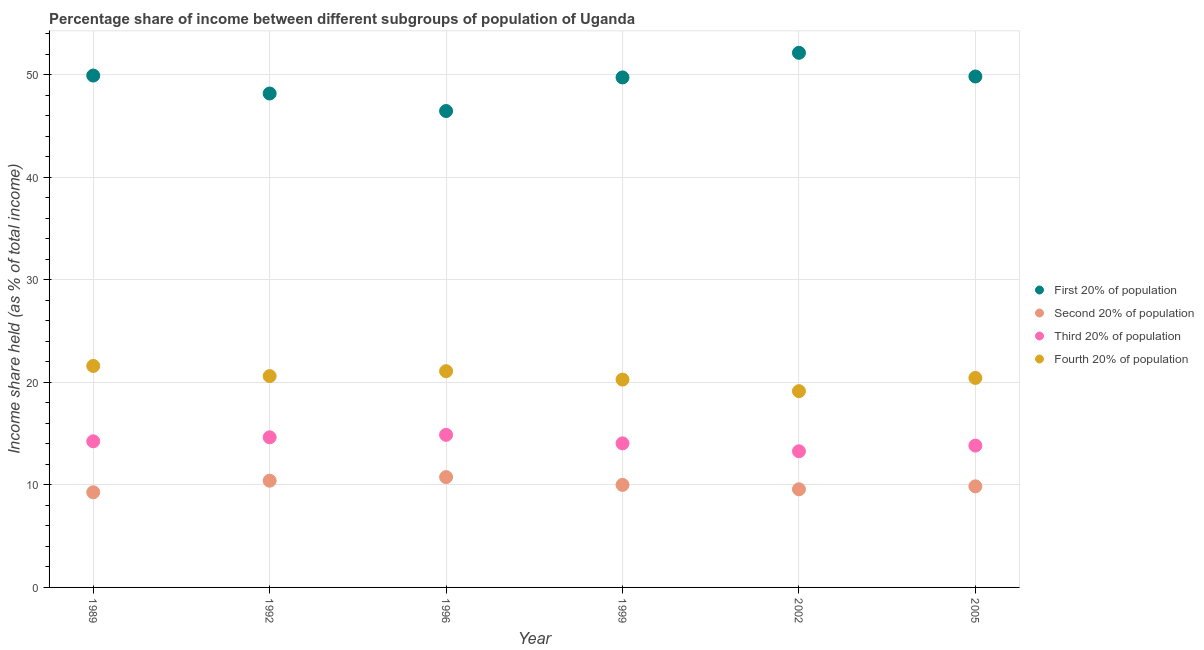Is the number of dotlines equal to the number of legend labels?
Ensure brevity in your answer.  Yes. What is the share of the income held by third 20% of the population in 2002?
Offer a very short reply. 13.28. Across all years, what is the maximum share of the income held by fourth 20% of the population?
Offer a terse response. 21.6. Across all years, what is the minimum share of the income held by first 20% of the population?
Offer a very short reply. 46.46. What is the total share of the income held by second 20% of the population in the graph?
Offer a terse response. 59.88. What is the difference between the share of the income held by third 20% of the population in 1999 and that in 2005?
Provide a succinct answer. 0.22. What is the difference between the share of the income held by third 20% of the population in 1989 and the share of the income held by second 20% of the population in 2005?
Your answer should be very brief. 4.39. What is the average share of the income held by fourth 20% of the population per year?
Provide a succinct answer. 20.52. In the year 1989, what is the difference between the share of the income held by first 20% of the population and share of the income held by fourth 20% of the population?
Your response must be concise. 28.32. What is the ratio of the share of the income held by fourth 20% of the population in 1989 to that in 2005?
Provide a succinct answer. 1.06. Is the share of the income held by first 20% of the population in 1989 less than that in 1996?
Ensure brevity in your answer.  No. Is the difference between the share of the income held by second 20% of the population in 2002 and 2005 greater than the difference between the share of the income held by first 20% of the population in 2002 and 2005?
Your answer should be compact. No. What is the difference between the highest and the second highest share of the income held by fourth 20% of the population?
Your answer should be very brief. 0.51. What is the difference between the highest and the lowest share of the income held by second 20% of the population?
Ensure brevity in your answer.  1.48. Is it the case that in every year, the sum of the share of the income held by first 20% of the population and share of the income held by second 20% of the population is greater than the share of the income held by third 20% of the population?
Keep it short and to the point. Yes. Does the share of the income held by first 20% of the population monotonically increase over the years?
Give a very brief answer. No. Is the share of the income held by fourth 20% of the population strictly less than the share of the income held by third 20% of the population over the years?
Give a very brief answer. No. How many dotlines are there?
Keep it short and to the point. 4. How many years are there in the graph?
Give a very brief answer. 6. Does the graph contain any zero values?
Your answer should be very brief. No. Does the graph contain grids?
Ensure brevity in your answer.  Yes. Where does the legend appear in the graph?
Your response must be concise. Center right. How many legend labels are there?
Provide a succinct answer. 4. What is the title of the graph?
Make the answer very short. Percentage share of income between different subgroups of population of Uganda. Does "Pre-primary schools" appear as one of the legend labels in the graph?
Make the answer very short. No. What is the label or title of the X-axis?
Your answer should be compact. Year. What is the label or title of the Y-axis?
Provide a succinct answer. Income share held (as % of total income). What is the Income share held (as % of total income) in First 20% of population in 1989?
Your response must be concise. 49.92. What is the Income share held (as % of total income) of Second 20% of population in 1989?
Make the answer very short. 9.28. What is the Income share held (as % of total income) of Third 20% of population in 1989?
Give a very brief answer. 14.25. What is the Income share held (as % of total income) in Fourth 20% of population in 1989?
Keep it short and to the point. 21.6. What is the Income share held (as % of total income) of First 20% of population in 1992?
Your response must be concise. 48.17. What is the Income share held (as % of total income) of Second 20% of population in 1992?
Make the answer very short. 10.41. What is the Income share held (as % of total income) in Third 20% of population in 1992?
Your response must be concise. 14.64. What is the Income share held (as % of total income) of Fourth 20% of population in 1992?
Make the answer very short. 20.61. What is the Income share held (as % of total income) of First 20% of population in 1996?
Make the answer very short. 46.46. What is the Income share held (as % of total income) of Second 20% of population in 1996?
Your response must be concise. 10.76. What is the Income share held (as % of total income) of Third 20% of population in 1996?
Ensure brevity in your answer.  14.88. What is the Income share held (as % of total income) in Fourth 20% of population in 1996?
Offer a terse response. 21.09. What is the Income share held (as % of total income) in First 20% of population in 1999?
Make the answer very short. 49.74. What is the Income share held (as % of total income) of Second 20% of population in 1999?
Your answer should be very brief. 10. What is the Income share held (as % of total income) in Third 20% of population in 1999?
Provide a short and direct response. 14.05. What is the Income share held (as % of total income) of Fourth 20% of population in 1999?
Ensure brevity in your answer.  20.27. What is the Income share held (as % of total income) in First 20% of population in 2002?
Provide a short and direct response. 52.14. What is the Income share held (as % of total income) in Second 20% of population in 2002?
Offer a terse response. 9.57. What is the Income share held (as % of total income) in Third 20% of population in 2002?
Provide a short and direct response. 13.28. What is the Income share held (as % of total income) of Fourth 20% of population in 2002?
Provide a succinct answer. 19.14. What is the Income share held (as % of total income) of First 20% of population in 2005?
Your answer should be compact. 49.83. What is the Income share held (as % of total income) of Second 20% of population in 2005?
Your answer should be compact. 9.86. What is the Income share held (as % of total income) of Third 20% of population in 2005?
Offer a terse response. 13.83. What is the Income share held (as % of total income) of Fourth 20% of population in 2005?
Provide a succinct answer. 20.43. Across all years, what is the maximum Income share held (as % of total income) in First 20% of population?
Keep it short and to the point. 52.14. Across all years, what is the maximum Income share held (as % of total income) of Second 20% of population?
Keep it short and to the point. 10.76. Across all years, what is the maximum Income share held (as % of total income) of Third 20% of population?
Provide a short and direct response. 14.88. Across all years, what is the maximum Income share held (as % of total income) in Fourth 20% of population?
Provide a short and direct response. 21.6. Across all years, what is the minimum Income share held (as % of total income) in First 20% of population?
Provide a short and direct response. 46.46. Across all years, what is the minimum Income share held (as % of total income) in Second 20% of population?
Provide a succinct answer. 9.28. Across all years, what is the minimum Income share held (as % of total income) in Third 20% of population?
Your response must be concise. 13.28. Across all years, what is the minimum Income share held (as % of total income) in Fourth 20% of population?
Provide a short and direct response. 19.14. What is the total Income share held (as % of total income) of First 20% of population in the graph?
Your answer should be compact. 296.26. What is the total Income share held (as % of total income) of Second 20% of population in the graph?
Provide a short and direct response. 59.88. What is the total Income share held (as % of total income) in Third 20% of population in the graph?
Your response must be concise. 84.93. What is the total Income share held (as % of total income) in Fourth 20% of population in the graph?
Your response must be concise. 123.14. What is the difference between the Income share held (as % of total income) of Second 20% of population in 1989 and that in 1992?
Keep it short and to the point. -1.13. What is the difference between the Income share held (as % of total income) of Third 20% of population in 1989 and that in 1992?
Offer a terse response. -0.39. What is the difference between the Income share held (as % of total income) in First 20% of population in 1989 and that in 1996?
Provide a short and direct response. 3.46. What is the difference between the Income share held (as % of total income) of Second 20% of population in 1989 and that in 1996?
Provide a succinct answer. -1.48. What is the difference between the Income share held (as % of total income) of Third 20% of population in 1989 and that in 1996?
Your response must be concise. -0.63. What is the difference between the Income share held (as % of total income) in Fourth 20% of population in 1989 and that in 1996?
Give a very brief answer. 0.51. What is the difference between the Income share held (as % of total income) in First 20% of population in 1989 and that in 1999?
Provide a succinct answer. 0.18. What is the difference between the Income share held (as % of total income) of Second 20% of population in 1989 and that in 1999?
Provide a succinct answer. -0.72. What is the difference between the Income share held (as % of total income) of Third 20% of population in 1989 and that in 1999?
Your answer should be compact. 0.2. What is the difference between the Income share held (as % of total income) of Fourth 20% of population in 1989 and that in 1999?
Offer a terse response. 1.33. What is the difference between the Income share held (as % of total income) of First 20% of population in 1989 and that in 2002?
Keep it short and to the point. -2.22. What is the difference between the Income share held (as % of total income) in Second 20% of population in 1989 and that in 2002?
Give a very brief answer. -0.29. What is the difference between the Income share held (as % of total income) of Fourth 20% of population in 1989 and that in 2002?
Ensure brevity in your answer.  2.46. What is the difference between the Income share held (as % of total income) of First 20% of population in 1989 and that in 2005?
Provide a succinct answer. 0.09. What is the difference between the Income share held (as % of total income) of Second 20% of population in 1989 and that in 2005?
Your response must be concise. -0.58. What is the difference between the Income share held (as % of total income) in Third 20% of population in 1989 and that in 2005?
Ensure brevity in your answer.  0.42. What is the difference between the Income share held (as % of total income) in Fourth 20% of population in 1989 and that in 2005?
Your answer should be very brief. 1.17. What is the difference between the Income share held (as % of total income) in First 20% of population in 1992 and that in 1996?
Your answer should be very brief. 1.71. What is the difference between the Income share held (as % of total income) in Second 20% of population in 1992 and that in 1996?
Provide a short and direct response. -0.35. What is the difference between the Income share held (as % of total income) in Third 20% of population in 1992 and that in 1996?
Make the answer very short. -0.24. What is the difference between the Income share held (as % of total income) in Fourth 20% of population in 1992 and that in 1996?
Offer a terse response. -0.48. What is the difference between the Income share held (as % of total income) of First 20% of population in 1992 and that in 1999?
Offer a terse response. -1.57. What is the difference between the Income share held (as % of total income) in Second 20% of population in 1992 and that in 1999?
Ensure brevity in your answer.  0.41. What is the difference between the Income share held (as % of total income) in Third 20% of population in 1992 and that in 1999?
Keep it short and to the point. 0.59. What is the difference between the Income share held (as % of total income) in Fourth 20% of population in 1992 and that in 1999?
Offer a terse response. 0.34. What is the difference between the Income share held (as % of total income) of First 20% of population in 1992 and that in 2002?
Offer a terse response. -3.97. What is the difference between the Income share held (as % of total income) in Second 20% of population in 1992 and that in 2002?
Give a very brief answer. 0.84. What is the difference between the Income share held (as % of total income) in Third 20% of population in 1992 and that in 2002?
Offer a very short reply. 1.36. What is the difference between the Income share held (as % of total income) of Fourth 20% of population in 1992 and that in 2002?
Your answer should be very brief. 1.47. What is the difference between the Income share held (as % of total income) in First 20% of population in 1992 and that in 2005?
Offer a terse response. -1.66. What is the difference between the Income share held (as % of total income) of Second 20% of population in 1992 and that in 2005?
Give a very brief answer. 0.55. What is the difference between the Income share held (as % of total income) of Third 20% of population in 1992 and that in 2005?
Keep it short and to the point. 0.81. What is the difference between the Income share held (as % of total income) in Fourth 20% of population in 1992 and that in 2005?
Offer a very short reply. 0.18. What is the difference between the Income share held (as % of total income) in First 20% of population in 1996 and that in 1999?
Provide a succinct answer. -3.28. What is the difference between the Income share held (as % of total income) of Second 20% of population in 1996 and that in 1999?
Your answer should be very brief. 0.76. What is the difference between the Income share held (as % of total income) in Third 20% of population in 1996 and that in 1999?
Your response must be concise. 0.83. What is the difference between the Income share held (as % of total income) of Fourth 20% of population in 1996 and that in 1999?
Your answer should be compact. 0.82. What is the difference between the Income share held (as % of total income) in First 20% of population in 1996 and that in 2002?
Provide a succinct answer. -5.68. What is the difference between the Income share held (as % of total income) of Second 20% of population in 1996 and that in 2002?
Keep it short and to the point. 1.19. What is the difference between the Income share held (as % of total income) of Fourth 20% of population in 1996 and that in 2002?
Your answer should be very brief. 1.95. What is the difference between the Income share held (as % of total income) of First 20% of population in 1996 and that in 2005?
Your answer should be very brief. -3.37. What is the difference between the Income share held (as % of total income) of Second 20% of population in 1996 and that in 2005?
Provide a succinct answer. 0.9. What is the difference between the Income share held (as % of total income) in Fourth 20% of population in 1996 and that in 2005?
Provide a short and direct response. 0.66. What is the difference between the Income share held (as % of total income) of Second 20% of population in 1999 and that in 2002?
Your answer should be compact. 0.43. What is the difference between the Income share held (as % of total income) in Third 20% of population in 1999 and that in 2002?
Provide a succinct answer. 0.77. What is the difference between the Income share held (as % of total income) in Fourth 20% of population in 1999 and that in 2002?
Offer a very short reply. 1.13. What is the difference between the Income share held (as % of total income) in First 20% of population in 1999 and that in 2005?
Your answer should be compact. -0.09. What is the difference between the Income share held (as % of total income) in Second 20% of population in 1999 and that in 2005?
Offer a very short reply. 0.14. What is the difference between the Income share held (as % of total income) in Third 20% of population in 1999 and that in 2005?
Your answer should be compact. 0.22. What is the difference between the Income share held (as % of total income) of Fourth 20% of population in 1999 and that in 2005?
Your answer should be compact. -0.16. What is the difference between the Income share held (as % of total income) of First 20% of population in 2002 and that in 2005?
Your response must be concise. 2.31. What is the difference between the Income share held (as % of total income) of Second 20% of population in 2002 and that in 2005?
Keep it short and to the point. -0.29. What is the difference between the Income share held (as % of total income) in Third 20% of population in 2002 and that in 2005?
Your response must be concise. -0.55. What is the difference between the Income share held (as % of total income) of Fourth 20% of population in 2002 and that in 2005?
Offer a terse response. -1.29. What is the difference between the Income share held (as % of total income) of First 20% of population in 1989 and the Income share held (as % of total income) of Second 20% of population in 1992?
Provide a short and direct response. 39.51. What is the difference between the Income share held (as % of total income) of First 20% of population in 1989 and the Income share held (as % of total income) of Third 20% of population in 1992?
Offer a terse response. 35.28. What is the difference between the Income share held (as % of total income) in First 20% of population in 1989 and the Income share held (as % of total income) in Fourth 20% of population in 1992?
Offer a terse response. 29.31. What is the difference between the Income share held (as % of total income) in Second 20% of population in 1989 and the Income share held (as % of total income) in Third 20% of population in 1992?
Provide a short and direct response. -5.36. What is the difference between the Income share held (as % of total income) of Second 20% of population in 1989 and the Income share held (as % of total income) of Fourth 20% of population in 1992?
Your response must be concise. -11.33. What is the difference between the Income share held (as % of total income) of Third 20% of population in 1989 and the Income share held (as % of total income) of Fourth 20% of population in 1992?
Keep it short and to the point. -6.36. What is the difference between the Income share held (as % of total income) in First 20% of population in 1989 and the Income share held (as % of total income) in Second 20% of population in 1996?
Offer a very short reply. 39.16. What is the difference between the Income share held (as % of total income) of First 20% of population in 1989 and the Income share held (as % of total income) of Third 20% of population in 1996?
Provide a succinct answer. 35.04. What is the difference between the Income share held (as % of total income) in First 20% of population in 1989 and the Income share held (as % of total income) in Fourth 20% of population in 1996?
Give a very brief answer. 28.83. What is the difference between the Income share held (as % of total income) in Second 20% of population in 1989 and the Income share held (as % of total income) in Third 20% of population in 1996?
Your response must be concise. -5.6. What is the difference between the Income share held (as % of total income) in Second 20% of population in 1989 and the Income share held (as % of total income) in Fourth 20% of population in 1996?
Make the answer very short. -11.81. What is the difference between the Income share held (as % of total income) in Third 20% of population in 1989 and the Income share held (as % of total income) in Fourth 20% of population in 1996?
Your response must be concise. -6.84. What is the difference between the Income share held (as % of total income) of First 20% of population in 1989 and the Income share held (as % of total income) of Second 20% of population in 1999?
Provide a short and direct response. 39.92. What is the difference between the Income share held (as % of total income) of First 20% of population in 1989 and the Income share held (as % of total income) of Third 20% of population in 1999?
Keep it short and to the point. 35.87. What is the difference between the Income share held (as % of total income) in First 20% of population in 1989 and the Income share held (as % of total income) in Fourth 20% of population in 1999?
Make the answer very short. 29.65. What is the difference between the Income share held (as % of total income) of Second 20% of population in 1989 and the Income share held (as % of total income) of Third 20% of population in 1999?
Provide a short and direct response. -4.77. What is the difference between the Income share held (as % of total income) of Second 20% of population in 1989 and the Income share held (as % of total income) of Fourth 20% of population in 1999?
Give a very brief answer. -10.99. What is the difference between the Income share held (as % of total income) of Third 20% of population in 1989 and the Income share held (as % of total income) of Fourth 20% of population in 1999?
Ensure brevity in your answer.  -6.02. What is the difference between the Income share held (as % of total income) of First 20% of population in 1989 and the Income share held (as % of total income) of Second 20% of population in 2002?
Ensure brevity in your answer.  40.35. What is the difference between the Income share held (as % of total income) in First 20% of population in 1989 and the Income share held (as % of total income) in Third 20% of population in 2002?
Your answer should be compact. 36.64. What is the difference between the Income share held (as % of total income) in First 20% of population in 1989 and the Income share held (as % of total income) in Fourth 20% of population in 2002?
Make the answer very short. 30.78. What is the difference between the Income share held (as % of total income) of Second 20% of population in 1989 and the Income share held (as % of total income) of Fourth 20% of population in 2002?
Your answer should be compact. -9.86. What is the difference between the Income share held (as % of total income) in Third 20% of population in 1989 and the Income share held (as % of total income) in Fourth 20% of population in 2002?
Your response must be concise. -4.89. What is the difference between the Income share held (as % of total income) of First 20% of population in 1989 and the Income share held (as % of total income) of Second 20% of population in 2005?
Your response must be concise. 40.06. What is the difference between the Income share held (as % of total income) of First 20% of population in 1989 and the Income share held (as % of total income) of Third 20% of population in 2005?
Ensure brevity in your answer.  36.09. What is the difference between the Income share held (as % of total income) in First 20% of population in 1989 and the Income share held (as % of total income) in Fourth 20% of population in 2005?
Provide a succinct answer. 29.49. What is the difference between the Income share held (as % of total income) of Second 20% of population in 1989 and the Income share held (as % of total income) of Third 20% of population in 2005?
Your response must be concise. -4.55. What is the difference between the Income share held (as % of total income) in Second 20% of population in 1989 and the Income share held (as % of total income) in Fourth 20% of population in 2005?
Provide a short and direct response. -11.15. What is the difference between the Income share held (as % of total income) of Third 20% of population in 1989 and the Income share held (as % of total income) of Fourth 20% of population in 2005?
Provide a succinct answer. -6.18. What is the difference between the Income share held (as % of total income) in First 20% of population in 1992 and the Income share held (as % of total income) in Second 20% of population in 1996?
Ensure brevity in your answer.  37.41. What is the difference between the Income share held (as % of total income) of First 20% of population in 1992 and the Income share held (as % of total income) of Third 20% of population in 1996?
Provide a succinct answer. 33.29. What is the difference between the Income share held (as % of total income) of First 20% of population in 1992 and the Income share held (as % of total income) of Fourth 20% of population in 1996?
Provide a succinct answer. 27.08. What is the difference between the Income share held (as % of total income) in Second 20% of population in 1992 and the Income share held (as % of total income) in Third 20% of population in 1996?
Give a very brief answer. -4.47. What is the difference between the Income share held (as % of total income) in Second 20% of population in 1992 and the Income share held (as % of total income) in Fourth 20% of population in 1996?
Your response must be concise. -10.68. What is the difference between the Income share held (as % of total income) of Third 20% of population in 1992 and the Income share held (as % of total income) of Fourth 20% of population in 1996?
Your response must be concise. -6.45. What is the difference between the Income share held (as % of total income) of First 20% of population in 1992 and the Income share held (as % of total income) of Second 20% of population in 1999?
Your answer should be compact. 38.17. What is the difference between the Income share held (as % of total income) in First 20% of population in 1992 and the Income share held (as % of total income) in Third 20% of population in 1999?
Ensure brevity in your answer.  34.12. What is the difference between the Income share held (as % of total income) of First 20% of population in 1992 and the Income share held (as % of total income) of Fourth 20% of population in 1999?
Offer a very short reply. 27.9. What is the difference between the Income share held (as % of total income) of Second 20% of population in 1992 and the Income share held (as % of total income) of Third 20% of population in 1999?
Give a very brief answer. -3.64. What is the difference between the Income share held (as % of total income) in Second 20% of population in 1992 and the Income share held (as % of total income) in Fourth 20% of population in 1999?
Offer a very short reply. -9.86. What is the difference between the Income share held (as % of total income) in Third 20% of population in 1992 and the Income share held (as % of total income) in Fourth 20% of population in 1999?
Offer a terse response. -5.63. What is the difference between the Income share held (as % of total income) of First 20% of population in 1992 and the Income share held (as % of total income) of Second 20% of population in 2002?
Offer a terse response. 38.6. What is the difference between the Income share held (as % of total income) of First 20% of population in 1992 and the Income share held (as % of total income) of Third 20% of population in 2002?
Offer a very short reply. 34.89. What is the difference between the Income share held (as % of total income) of First 20% of population in 1992 and the Income share held (as % of total income) of Fourth 20% of population in 2002?
Make the answer very short. 29.03. What is the difference between the Income share held (as % of total income) of Second 20% of population in 1992 and the Income share held (as % of total income) of Third 20% of population in 2002?
Your answer should be compact. -2.87. What is the difference between the Income share held (as % of total income) in Second 20% of population in 1992 and the Income share held (as % of total income) in Fourth 20% of population in 2002?
Offer a terse response. -8.73. What is the difference between the Income share held (as % of total income) in First 20% of population in 1992 and the Income share held (as % of total income) in Second 20% of population in 2005?
Keep it short and to the point. 38.31. What is the difference between the Income share held (as % of total income) of First 20% of population in 1992 and the Income share held (as % of total income) of Third 20% of population in 2005?
Keep it short and to the point. 34.34. What is the difference between the Income share held (as % of total income) of First 20% of population in 1992 and the Income share held (as % of total income) of Fourth 20% of population in 2005?
Your answer should be very brief. 27.74. What is the difference between the Income share held (as % of total income) of Second 20% of population in 1992 and the Income share held (as % of total income) of Third 20% of population in 2005?
Provide a short and direct response. -3.42. What is the difference between the Income share held (as % of total income) in Second 20% of population in 1992 and the Income share held (as % of total income) in Fourth 20% of population in 2005?
Your answer should be very brief. -10.02. What is the difference between the Income share held (as % of total income) of Third 20% of population in 1992 and the Income share held (as % of total income) of Fourth 20% of population in 2005?
Keep it short and to the point. -5.79. What is the difference between the Income share held (as % of total income) of First 20% of population in 1996 and the Income share held (as % of total income) of Second 20% of population in 1999?
Give a very brief answer. 36.46. What is the difference between the Income share held (as % of total income) of First 20% of population in 1996 and the Income share held (as % of total income) of Third 20% of population in 1999?
Provide a short and direct response. 32.41. What is the difference between the Income share held (as % of total income) in First 20% of population in 1996 and the Income share held (as % of total income) in Fourth 20% of population in 1999?
Your response must be concise. 26.19. What is the difference between the Income share held (as % of total income) of Second 20% of population in 1996 and the Income share held (as % of total income) of Third 20% of population in 1999?
Your answer should be very brief. -3.29. What is the difference between the Income share held (as % of total income) of Second 20% of population in 1996 and the Income share held (as % of total income) of Fourth 20% of population in 1999?
Provide a succinct answer. -9.51. What is the difference between the Income share held (as % of total income) of Third 20% of population in 1996 and the Income share held (as % of total income) of Fourth 20% of population in 1999?
Ensure brevity in your answer.  -5.39. What is the difference between the Income share held (as % of total income) of First 20% of population in 1996 and the Income share held (as % of total income) of Second 20% of population in 2002?
Make the answer very short. 36.89. What is the difference between the Income share held (as % of total income) in First 20% of population in 1996 and the Income share held (as % of total income) in Third 20% of population in 2002?
Your answer should be very brief. 33.18. What is the difference between the Income share held (as % of total income) in First 20% of population in 1996 and the Income share held (as % of total income) in Fourth 20% of population in 2002?
Provide a succinct answer. 27.32. What is the difference between the Income share held (as % of total income) of Second 20% of population in 1996 and the Income share held (as % of total income) of Third 20% of population in 2002?
Keep it short and to the point. -2.52. What is the difference between the Income share held (as % of total income) of Second 20% of population in 1996 and the Income share held (as % of total income) of Fourth 20% of population in 2002?
Offer a very short reply. -8.38. What is the difference between the Income share held (as % of total income) of Third 20% of population in 1996 and the Income share held (as % of total income) of Fourth 20% of population in 2002?
Keep it short and to the point. -4.26. What is the difference between the Income share held (as % of total income) in First 20% of population in 1996 and the Income share held (as % of total income) in Second 20% of population in 2005?
Your answer should be compact. 36.6. What is the difference between the Income share held (as % of total income) in First 20% of population in 1996 and the Income share held (as % of total income) in Third 20% of population in 2005?
Keep it short and to the point. 32.63. What is the difference between the Income share held (as % of total income) of First 20% of population in 1996 and the Income share held (as % of total income) of Fourth 20% of population in 2005?
Provide a succinct answer. 26.03. What is the difference between the Income share held (as % of total income) of Second 20% of population in 1996 and the Income share held (as % of total income) of Third 20% of population in 2005?
Provide a short and direct response. -3.07. What is the difference between the Income share held (as % of total income) in Second 20% of population in 1996 and the Income share held (as % of total income) in Fourth 20% of population in 2005?
Make the answer very short. -9.67. What is the difference between the Income share held (as % of total income) in Third 20% of population in 1996 and the Income share held (as % of total income) in Fourth 20% of population in 2005?
Offer a very short reply. -5.55. What is the difference between the Income share held (as % of total income) in First 20% of population in 1999 and the Income share held (as % of total income) in Second 20% of population in 2002?
Your answer should be compact. 40.17. What is the difference between the Income share held (as % of total income) in First 20% of population in 1999 and the Income share held (as % of total income) in Third 20% of population in 2002?
Provide a succinct answer. 36.46. What is the difference between the Income share held (as % of total income) of First 20% of population in 1999 and the Income share held (as % of total income) of Fourth 20% of population in 2002?
Offer a terse response. 30.6. What is the difference between the Income share held (as % of total income) in Second 20% of population in 1999 and the Income share held (as % of total income) in Third 20% of population in 2002?
Offer a terse response. -3.28. What is the difference between the Income share held (as % of total income) in Second 20% of population in 1999 and the Income share held (as % of total income) in Fourth 20% of population in 2002?
Your response must be concise. -9.14. What is the difference between the Income share held (as % of total income) in Third 20% of population in 1999 and the Income share held (as % of total income) in Fourth 20% of population in 2002?
Offer a very short reply. -5.09. What is the difference between the Income share held (as % of total income) of First 20% of population in 1999 and the Income share held (as % of total income) of Second 20% of population in 2005?
Your response must be concise. 39.88. What is the difference between the Income share held (as % of total income) in First 20% of population in 1999 and the Income share held (as % of total income) in Third 20% of population in 2005?
Your answer should be very brief. 35.91. What is the difference between the Income share held (as % of total income) of First 20% of population in 1999 and the Income share held (as % of total income) of Fourth 20% of population in 2005?
Your response must be concise. 29.31. What is the difference between the Income share held (as % of total income) of Second 20% of population in 1999 and the Income share held (as % of total income) of Third 20% of population in 2005?
Provide a short and direct response. -3.83. What is the difference between the Income share held (as % of total income) in Second 20% of population in 1999 and the Income share held (as % of total income) in Fourth 20% of population in 2005?
Offer a terse response. -10.43. What is the difference between the Income share held (as % of total income) of Third 20% of population in 1999 and the Income share held (as % of total income) of Fourth 20% of population in 2005?
Offer a very short reply. -6.38. What is the difference between the Income share held (as % of total income) of First 20% of population in 2002 and the Income share held (as % of total income) of Second 20% of population in 2005?
Offer a terse response. 42.28. What is the difference between the Income share held (as % of total income) of First 20% of population in 2002 and the Income share held (as % of total income) of Third 20% of population in 2005?
Your answer should be compact. 38.31. What is the difference between the Income share held (as % of total income) in First 20% of population in 2002 and the Income share held (as % of total income) in Fourth 20% of population in 2005?
Your answer should be compact. 31.71. What is the difference between the Income share held (as % of total income) of Second 20% of population in 2002 and the Income share held (as % of total income) of Third 20% of population in 2005?
Offer a very short reply. -4.26. What is the difference between the Income share held (as % of total income) of Second 20% of population in 2002 and the Income share held (as % of total income) of Fourth 20% of population in 2005?
Provide a short and direct response. -10.86. What is the difference between the Income share held (as % of total income) in Third 20% of population in 2002 and the Income share held (as % of total income) in Fourth 20% of population in 2005?
Ensure brevity in your answer.  -7.15. What is the average Income share held (as % of total income) of First 20% of population per year?
Your response must be concise. 49.38. What is the average Income share held (as % of total income) in Second 20% of population per year?
Your answer should be compact. 9.98. What is the average Income share held (as % of total income) of Third 20% of population per year?
Give a very brief answer. 14.15. What is the average Income share held (as % of total income) in Fourth 20% of population per year?
Make the answer very short. 20.52. In the year 1989, what is the difference between the Income share held (as % of total income) in First 20% of population and Income share held (as % of total income) in Second 20% of population?
Provide a succinct answer. 40.64. In the year 1989, what is the difference between the Income share held (as % of total income) in First 20% of population and Income share held (as % of total income) in Third 20% of population?
Ensure brevity in your answer.  35.67. In the year 1989, what is the difference between the Income share held (as % of total income) in First 20% of population and Income share held (as % of total income) in Fourth 20% of population?
Offer a very short reply. 28.32. In the year 1989, what is the difference between the Income share held (as % of total income) of Second 20% of population and Income share held (as % of total income) of Third 20% of population?
Make the answer very short. -4.97. In the year 1989, what is the difference between the Income share held (as % of total income) in Second 20% of population and Income share held (as % of total income) in Fourth 20% of population?
Your answer should be very brief. -12.32. In the year 1989, what is the difference between the Income share held (as % of total income) of Third 20% of population and Income share held (as % of total income) of Fourth 20% of population?
Provide a succinct answer. -7.35. In the year 1992, what is the difference between the Income share held (as % of total income) in First 20% of population and Income share held (as % of total income) in Second 20% of population?
Keep it short and to the point. 37.76. In the year 1992, what is the difference between the Income share held (as % of total income) of First 20% of population and Income share held (as % of total income) of Third 20% of population?
Your response must be concise. 33.53. In the year 1992, what is the difference between the Income share held (as % of total income) of First 20% of population and Income share held (as % of total income) of Fourth 20% of population?
Your response must be concise. 27.56. In the year 1992, what is the difference between the Income share held (as % of total income) of Second 20% of population and Income share held (as % of total income) of Third 20% of population?
Your answer should be compact. -4.23. In the year 1992, what is the difference between the Income share held (as % of total income) of Third 20% of population and Income share held (as % of total income) of Fourth 20% of population?
Provide a succinct answer. -5.97. In the year 1996, what is the difference between the Income share held (as % of total income) in First 20% of population and Income share held (as % of total income) in Second 20% of population?
Ensure brevity in your answer.  35.7. In the year 1996, what is the difference between the Income share held (as % of total income) of First 20% of population and Income share held (as % of total income) of Third 20% of population?
Keep it short and to the point. 31.58. In the year 1996, what is the difference between the Income share held (as % of total income) of First 20% of population and Income share held (as % of total income) of Fourth 20% of population?
Ensure brevity in your answer.  25.37. In the year 1996, what is the difference between the Income share held (as % of total income) in Second 20% of population and Income share held (as % of total income) in Third 20% of population?
Your answer should be very brief. -4.12. In the year 1996, what is the difference between the Income share held (as % of total income) of Second 20% of population and Income share held (as % of total income) of Fourth 20% of population?
Make the answer very short. -10.33. In the year 1996, what is the difference between the Income share held (as % of total income) in Third 20% of population and Income share held (as % of total income) in Fourth 20% of population?
Ensure brevity in your answer.  -6.21. In the year 1999, what is the difference between the Income share held (as % of total income) of First 20% of population and Income share held (as % of total income) of Second 20% of population?
Offer a very short reply. 39.74. In the year 1999, what is the difference between the Income share held (as % of total income) in First 20% of population and Income share held (as % of total income) in Third 20% of population?
Offer a terse response. 35.69. In the year 1999, what is the difference between the Income share held (as % of total income) of First 20% of population and Income share held (as % of total income) of Fourth 20% of population?
Offer a terse response. 29.47. In the year 1999, what is the difference between the Income share held (as % of total income) in Second 20% of population and Income share held (as % of total income) in Third 20% of population?
Provide a short and direct response. -4.05. In the year 1999, what is the difference between the Income share held (as % of total income) of Second 20% of population and Income share held (as % of total income) of Fourth 20% of population?
Your answer should be compact. -10.27. In the year 1999, what is the difference between the Income share held (as % of total income) in Third 20% of population and Income share held (as % of total income) in Fourth 20% of population?
Give a very brief answer. -6.22. In the year 2002, what is the difference between the Income share held (as % of total income) of First 20% of population and Income share held (as % of total income) of Second 20% of population?
Your answer should be very brief. 42.57. In the year 2002, what is the difference between the Income share held (as % of total income) of First 20% of population and Income share held (as % of total income) of Third 20% of population?
Give a very brief answer. 38.86. In the year 2002, what is the difference between the Income share held (as % of total income) of First 20% of population and Income share held (as % of total income) of Fourth 20% of population?
Your answer should be very brief. 33. In the year 2002, what is the difference between the Income share held (as % of total income) of Second 20% of population and Income share held (as % of total income) of Third 20% of population?
Make the answer very short. -3.71. In the year 2002, what is the difference between the Income share held (as % of total income) of Second 20% of population and Income share held (as % of total income) of Fourth 20% of population?
Your answer should be compact. -9.57. In the year 2002, what is the difference between the Income share held (as % of total income) of Third 20% of population and Income share held (as % of total income) of Fourth 20% of population?
Your answer should be compact. -5.86. In the year 2005, what is the difference between the Income share held (as % of total income) of First 20% of population and Income share held (as % of total income) of Second 20% of population?
Keep it short and to the point. 39.97. In the year 2005, what is the difference between the Income share held (as % of total income) of First 20% of population and Income share held (as % of total income) of Fourth 20% of population?
Offer a very short reply. 29.4. In the year 2005, what is the difference between the Income share held (as % of total income) of Second 20% of population and Income share held (as % of total income) of Third 20% of population?
Make the answer very short. -3.97. In the year 2005, what is the difference between the Income share held (as % of total income) of Second 20% of population and Income share held (as % of total income) of Fourth 20% of population?
Offer a very short reply. -10.57. What is the ratio of the Income share held (as % of total income) in First 20% of population in 1989 to that in 1992?
Your response must be concise. 1.04. What is the ratio of the Income share held (as % of total income) in Second 20% of population in 1989 to that in 1992?
Offer a terse response. 0.89. What is the ratio of the Income share held (as % of total income) of Third 20% of population in 1989 to that in 1992?
Keep it short and to the point. 0.97. What is the ratio of the Income share held (as % of total income) in Fourth 20% of population in 1989 to that in 1992?
Your answer should be compact. 1.05. What is the ratio of the Income share held (as % of total income) of First 20% of population in 1989 to that in 1996?
Provide a succinct answer. 1.07. What is the ratio of the Income share held (as % of total income) of Second 20% of population in 1989 to that in 1996?
Provide a short and direct response. 0.86. What is the ratio of the Income share held (as % of total income) in Third 20% of population in 1989 to that in 1996?
Provide a succinct answer. 0.96. What is the ratio of the Income share held (as % of total income) in Fourth 20% of population in 1989 to that in 1996?
Give a very brief answer. 1.02. What is the ratio of the Income share held (as % of total income) of First 20% of population in 1989 to that in 1999?
Ensure brevity in your answer.  1. What is the ratio of the Income share held (as % of total income) in Second 20% of population in 1989 to that in 1999?
Give a very brief answer. 0.93. What is the ratio of the Income share held (as % of total income) of Third 20% of population in 1989 to that in 1999?
Offer a very short reply. 1.01. What is the ratio of the Income share held (as % of total income) of Fourth 20% of population in 1989 to that in 1999?
Offer a very short reply. 1.07. What is the ratio of the Income share held (as % of total income) in First 20% of population in 1989 to that in 2002?
Your response must be concise. 0.96. What is the ratio of the Income share held (as % of total income) in Second 20% of population in 1989 to that in 2002?
Your response must be concise. 0.97. What is the ratio of the Income share held (as % of total income) in Third 20% of population in 1989 to that in 2002?
Make the answer very short. 1.07. What is the ratio of the Income share held (as % of total income) in Fourth 20% of population in 1989 to that in 2002?
Your response must be concise. 1.13. What is the ratio of the Income share held (as % of total income) of First 20% of population in 1989 to that in 2005?
Keep it short and to the point. 1. What is the ratio of the Income share held (as % of total income) in Third 20% of population in 1989 to that in 2005?
Your answer should be compact. 1.03. What is the ratio of the Income share held (as % of total income) of Fourth 20% of population in 1989 to that in 2005?
Provide a succinct answer. 1.06. What is the ratio of the Income share held (as % of total income) of First 20% of population in 1992 to that in 1996?
Your response must be concise. 1.04. What is the ratio of the Income share held (as % of total income) of Second 20% of population in 1992 to that in 1996?
Offer a very short reply. 0.97. What is the ratio of the Income share held (as % of total income) of Third 20% of population in 1992 to that in 1996?
Ensure brevity in your answer.  0.98. What is the ratio of the Income share held (as % of total income) in Fourth 20% of population in 1992 to that in 1996?
Make the answer very short. 0.98. What is the ratio of the Income share held (as % of total income) in First 20% of population in 1992 to that in 1999?
Offer a terse response. 0.97. What is the ratio of the Income share held (as % of total income) of Second 20% of population in 1992 to that in 1999?
Give a very brief answer. 1.04. What is the ratio of the Income share held (as % of total income) in Third 20% of population in 1992 to that in 1999?
Offer a very short reply. 1.04. What is the ratio of the Income share held (as % of total income) of Fourth 20% of population in 1992 to that in 1999?
Provide a succinct answer. 1.02. What is the ratio of the Income share held (as % of total income) of First 20% of population in 1992 to that in 2002?
Your answer should be very brief. 0.92. What is the ratio of the Income share held (as % of total income) in Second 20% of population in 1992 to that in 2002?
Provide a short and direct response. 1.09. What is the ratio of the Income share held (as % of total income) in Third 20% of population in 1992 to that in 2002?
Give a very brief answer. 1.1. What is the ratio of the Income share held (as % of total income) in Fourth 20% of population in 1992 to that in 2002?
Offer a terse response. 1.08. What is the ratio of the Income share held (as % of total income) in First 20% of population in 1992 to that in 2005?
Your answer should be very brief. 0.97. What is the ratio of the Income share held (as % of total income) in Second 20% of population in 1992 to that in 2005?
Keep it short and to the point. 1.06. What is the ratio of the Income share held (as % of total income) in Third 20% of population in 1992 to that in 2005?
Provide a short and direct response. 1.06. What is the ratio of the Income share held (as % of total income) of Fourth 20% of population in 1992 to that in 2005?
Offer a very short reply. 1.01. What is the ratio of the Income share held (as % of total income) in First 20% of population in 1996 to that in 1999?
Your answer should be very brief. 0.93. What is the ratio of the Income share held (as % of total income) of Second 20% of population in 1996 to that in 1999?
Provide a short and direct response. 1.08. What is the ratio of the Income share held (as % of total income) in Third 20% of population in 1996 to that in 1999?
Give a very brief answer. 1.06. What is the ratio of the Income share held (as % of total income) of Fourth 20% of population in 1996 to that in 1999?
Provide a short and direct response. 1.04. What is the ratio of the Income share held (as % of total income) of First 20% of population in 1996 to that in 2002?
Your answer should be very brief. 0.89. What is the ratio of the Income share held (as % of total income) of Second 20% of population in 1996 to that in 2002?
Offer a terse response. 1.12. What is the ratio of the Income share held (as % of total income) in Third 20% of population in 1996 to that in 2002?
Offer a terse response. 1.12. What is the ratio of the Income share held (as % of total income) of Fourth 20% of population in 1996 to that in 2002?
Provide a short and direct response. 1.1. What is the ratio of the Income share held (as % of total income) of First 20% of population in 1996 to that in 2005?
Keep it short and to the point. 0.93. What is the ratio of the Income share held (as % of total income) of Second 20% of population in 1996 to that in 2005?
Your response must be concise. 1.09. What is the ratio of the Income share held (as % of total income) in Third 20% of population in 1996 to that in 2005?
Your answer should be very brief. 1.08. What is the ratio of the Income share held (as % of total income) of Fourth 20% of population in 1996 to that in 2005?
Make the answer very short. 1.03. What is the ratio of the Income share held (as % of total income) in First 20% of population in 1999 to that in 2002?
Offer a very short reply. 0.95. What is the ratio of the Income share held (as % of total income) of Second 20% of population in 1999 to that in 2002?
Provide a short and direct response. 1.04. What is the ratio of the Income share held (as % of total income) of Third 20% of population in 1999 to that in 2002?
Provide a short and direct response. 1.06. What is the ratio of the Income share held (as % of total income) of Fourth 20% of population in 1999 to that in 2002?
Make the answer very short. 1.06. What is the ratio of the Income share held (as % of total income) of Second 20% of population in 1999 to that in 2005?
Give a very brief answer. 1.01. What is the ratio of the Income share held (as % of total income) in Third 20% of population in 1999 to that in 2005?
Make the answer very short. 1.02. What is the ratio of the Income share held (as % of total income) in First 20% of population in 2002 to that in 2005?
Provide a short and direct response. 1.05. What is the ratio of the Income share held (as % of total income) in Second 20% of population in 2002 to that in 2005?
Ensure brevity in your answer.  0.97. What is the ratio of the Income share held (as % of total income) of Third 20% of population in 2002 to that in 2005?
Your answer should be very brief. 0.96. What is the ratio of the Income share held (as % of total income) of Fourth 20% of population in 2002 to that in 2005?
Ensure brevity in your answer.  0.94. What is the difference between the highest and the second highest Income share held (as % of total income) of First 20% of population?
Offer a terse response. 2.22. What is the difference between the highest and the second highest Income share held (as % of total income) in Second 20% of population?
Your answer should be compact. 0.35. What is the difference between the highest and the second highest Income share held (as % of total income) of Third 20% of population?
Make the answer very short. 0.24. What is the difference between the highest and the second highest Income share held (as % of total income) of Fourth 20% of population?
Keep it short and to the point. 0.51. What is the difference between the highest and the lowest Income share held (as % of total income) in First 20% of population?
Ensure brevity in your answer.  5.68. What is the difference between the highest and the lowest Income share held (as % of total income) in Second 20% of population?
Offer a terse response. 1.48. What is the difference between the highest and the lowest Income share held (as % of total income) of Third 20% of population?
Your answer should be compact. 1.6. What is the difference between the highest and the lowest Income share held (as % of total income) of Fourth 20% of population?
Your response must be concise. 2.46. 